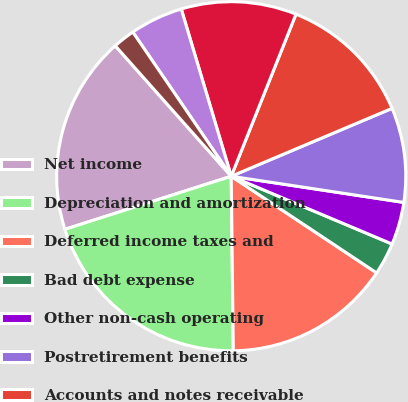Convert chart to OTSL. <chart><loc_0><loc_0><loc_500><loc_500><pie_chart><fcel>Net income<fcel>Depreciation and amortization<fcel>Deferred income taxes and<fcel>Bad debt expense<fcel>Other non-cash operating<fcel>Postretirement benefits<fcel>Accounts and notes receivable<fcel>Inventories<fcel>Accounts payable and accrued<fcel>Other current and non-current<nl><fcel>18.35%<fcel>20.27%<fcel>15.47%<fcel>2.99%<fcel>3.95%<fcel>8.75%<fcel>12.59%<fcel>10.67%<fcel>4.91%<fcel>2.03%<nl></chart> 